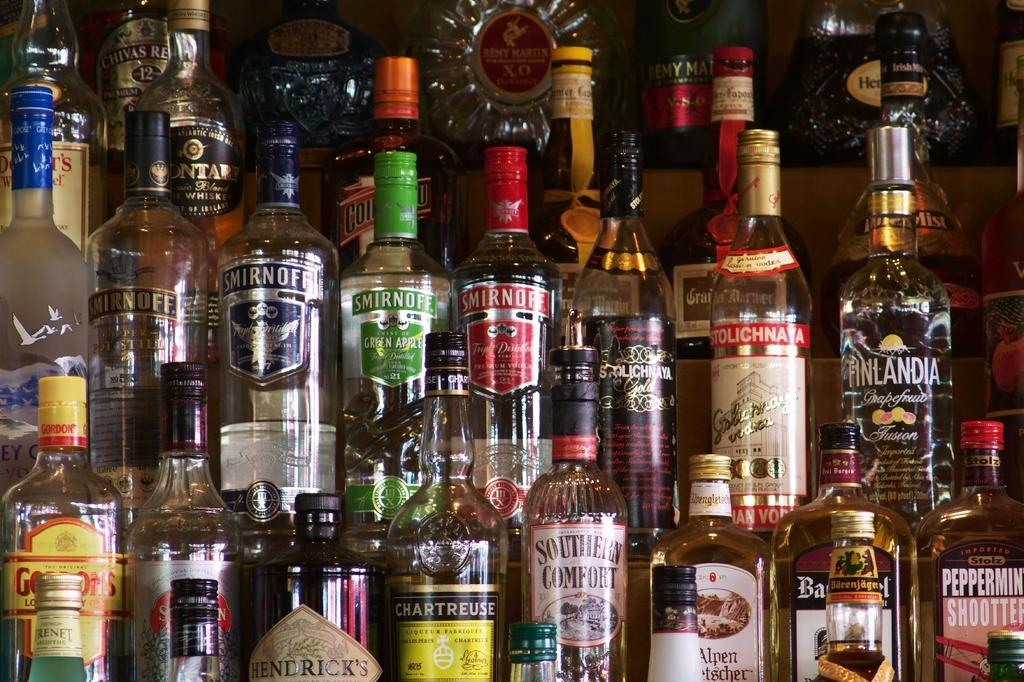<image>
Render a clear and concise summary of the photo. A shelf of liqour including Smirnoff and Stolichayna. 